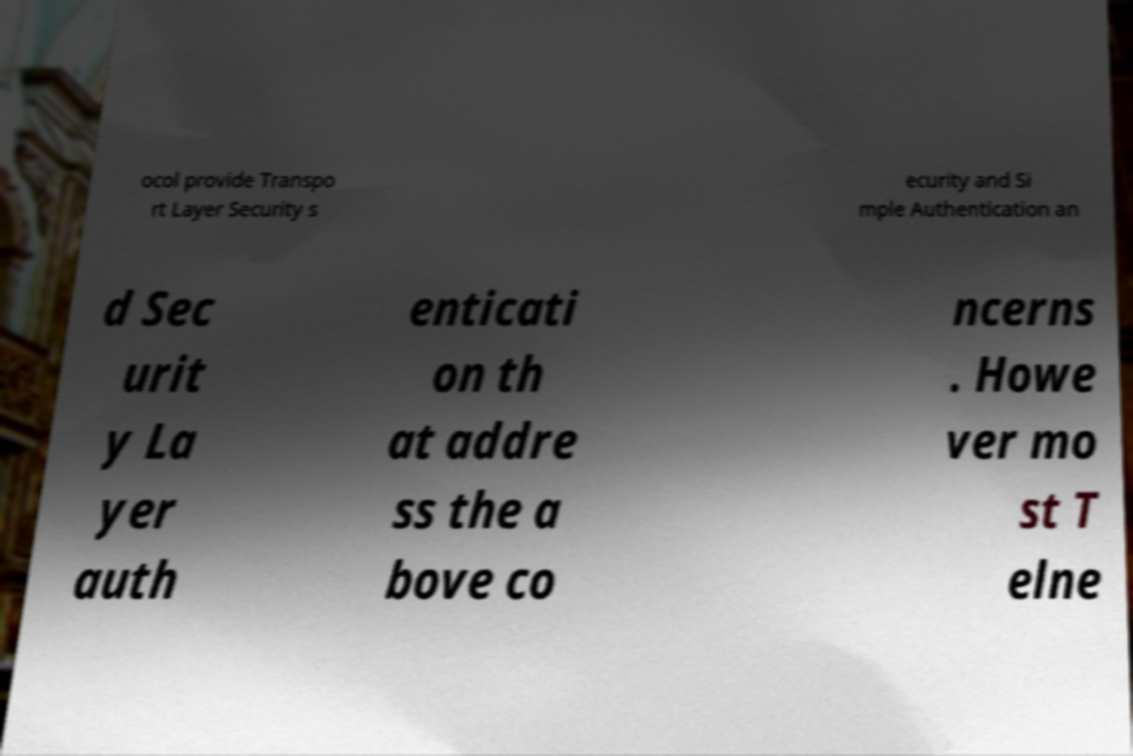Can you accurately transcribe the text from the provided image for me? ocol provide Transpo rt Layer Security s ecurity and Si mple Authentication an d Sec urit y La yer auth enticati on th at addre ss the a bove co ncerns . Howe ver mo st T elne 